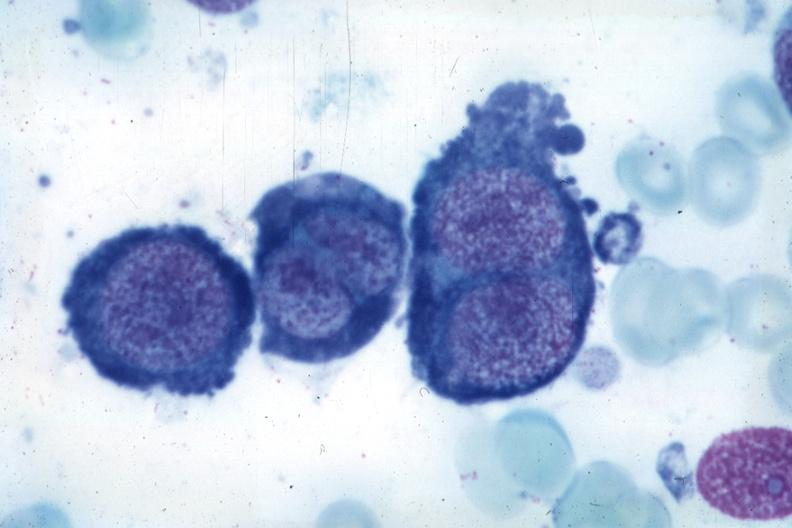s accessory spleens present?
Answer the question using a single word or phrase. No 